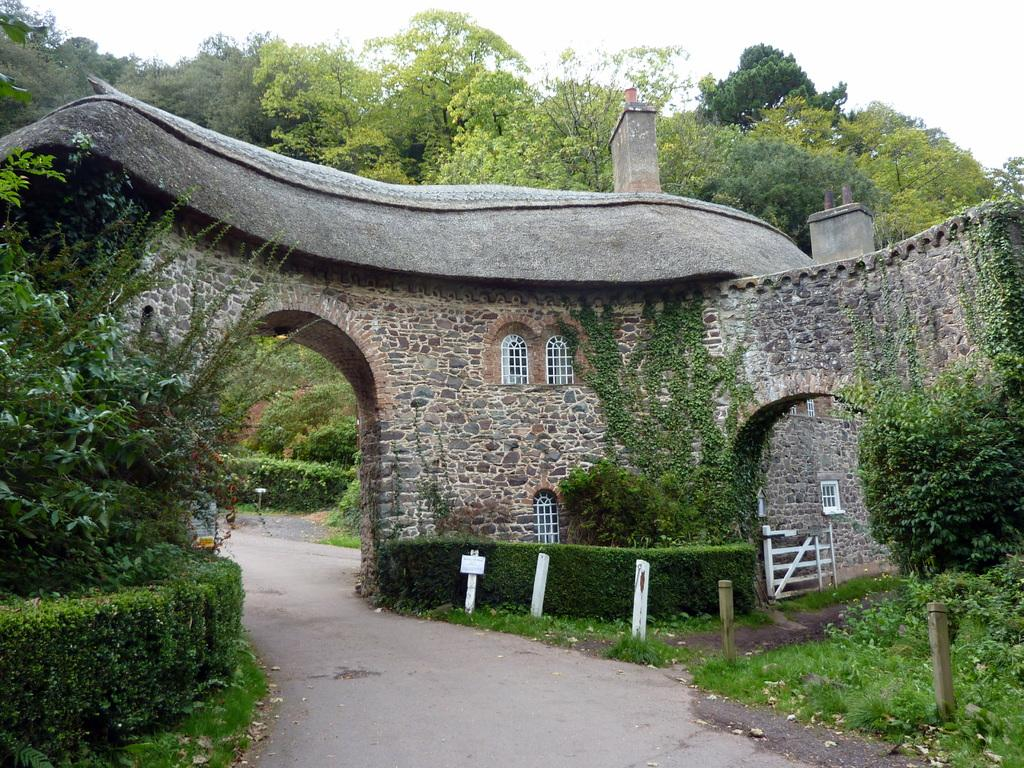What is the main feature of the image? There is a road in the image. What can be seen on either side of the road? There are plants on either side of the road. What is visible in the background of the image? There is a monument and trees in the background of the image, as well as the sky. What type of oatmeal is being served at the monument in the image? There is no oatmeal or indication of food in the image; it features a road with plants on either side and a monument in the background. 